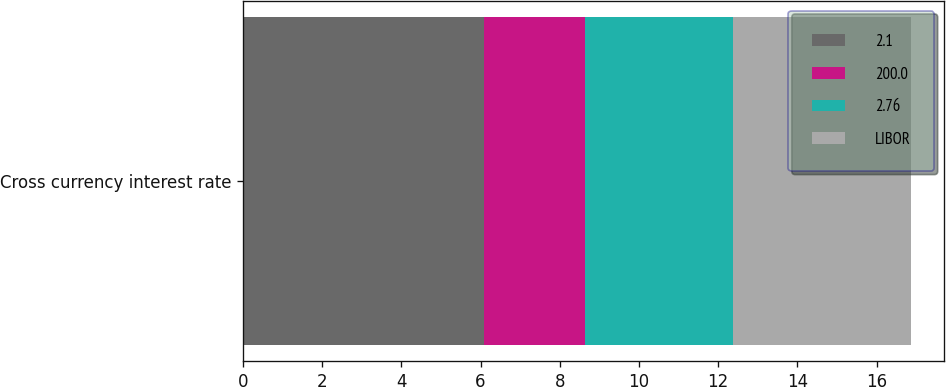<chart> <loc_0><loc_0><loc_500><loc_500><stacked_bar_chart><ecel><fcel>Cross currency interest rate<nl><fcel>2.1<fcel>6.1<nl><fcel>200.0<fcel>2.55<nl><fcel>2.76<fcel>3.72<nl><fcel>LIBOR<fcel>4.5<nl></chart> 